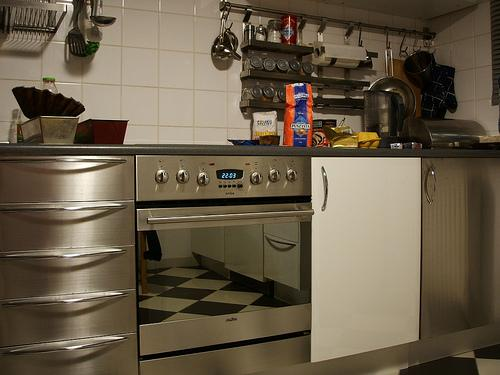Mention any special item hanging in the kitchen. A dark oven mitt is hanging on a rack. List all the visible hanging items in the kitchen. A hanging frying pan, dark oven mitt, steel pan, small silver funnel, kitchen utensils, and a pan on a hook. Describe the appearance of the oven in the image. The oven is shiny stainless steel, with a long handle, blue digital numbers on the front, and six metal knobs. What color is the food bag on the kitchen counter? The food bag on the kitchen counter is blue and red. What is the primary activity occurring in this image? There is no primary activity, as the image shows various objects in a kitchen. Identify the type of room where the image is taken. The image is taken in a kitchen. What types of handles are in the kitchen? There are long stainless steel oven and kitchen cabinet handles, and several handles on drawers. What kind of tiles can be seen on the walls and floor? White tiles on the walls and black and white checkered tiles on the floor. Explain the pattern seen on the floor and its reflection. The floor has a black and white checkered pattern which can also be seen reflected in the oven door. How many oven knobs are visible in the image? There are six metal oven knobs visible. Are there any food items on the countertop? Yes, a bag and a pan Is there a reflection of the patterned floor visible in the scene? Yes, in the oven door Describe the kitchen layout with respect to the cabinets and oven. A white cabinet beside the stove and a silver cupboard next to the white one What is the dominant feature of the kitchen walls? White tiles What is the appearance of the cabinet handles? Shiny stainless steel What is the most distinctive aspect of the cabinet doors? The shiny stainless steel handles List the items seen on the countertop in the image. A bag, a pan, a blue and red food bag, several products, and a packet of floor Is there a yellow mitt hanging on the rack? There is a dark oven mitt hanging on a rack, but it is not yellow, it is dark-colored. Is the bottle in the kitchen orange? There is a bottle in the kitchen, but the color of the bottle is not specified in the image information. Can you read the time displayed on the stove? No, the time is not clear What is the color of the hanging oven mitt? Dark Which appliance has a reflection on its surface? Oven Identify the hanging kitchen utensils in the image. A steel pan, a dark oven mitt, a small silver funnel, and kitchen utensils on a rack What is hanging alongside the steel pan? A dark oven mitt Write a descriptive sentence about the oven and its features. The shiny steel kitchen oven has six metal knobs, a long stainless steel handle, and blue digital numbers on the front. Can you see the red knobs on the stove? The knobs on the stove are not red, they are stainless steel. Is there a spice rack in the image? If so, state its location. Yes, on the wall Can you find a pet in the kitchen? There is no mention of a pet in the image. Describe the floor pattern in the kitchen. Black and white checkered Did you notice a green packet on the shelf? There is a packet on the shelf, but it is not green. The color of the packet is not specified in the image information. Explain the arrangement of the hanging kitchen appliances and their relationship to each other. The hanging kitchen appliances are placed against the wall on a rail, including a steel pan, dark oven mitt, small silver funnel, and kitchen utensils on a rack. Create a summary of the kitchen scene incorporating the key elements. A kitchen with white tiled walls, checkered floor, hanging kitchen utensils, several cabinets with shiny stainless steel handles, and a shiny steel oven with a reflection. Are there any square tiles on the floor? The tiles on the floor have a black and white checkered pattern, but their shape is not mentioned in the image information. Describe the wall-mounted objects in the kitchen. Spice rack, rail with hanging kitchen appliances and utensils, and a red canister on a shelf 